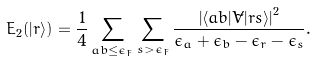<formula> <loc_0><loc_0><loc_500><loc_500>E _ { 2 } ( | r \rangle ) = \frac { 1 } { 4 } \sum _ { a b \leq \epsilon _ { F } } \sum _ { s > \epsilon _ { F } } \frac { \left | \langle a b | \tilde { V } | r s \rangle \right | ^ { 2 } } { \epsilon _ { a } + \epsilon _ { b } - \epsilon _ { r } - \epsilon _ { s } } .</formula> 